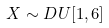Convert formula to latex. <formula><loc_0><loc_0><loc_500><loc_500>X \sim D U [ 1 , 6 ]</formula> 